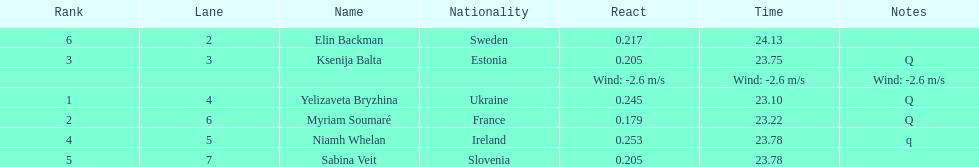Who finished after sabina veit? Elin Backman. 